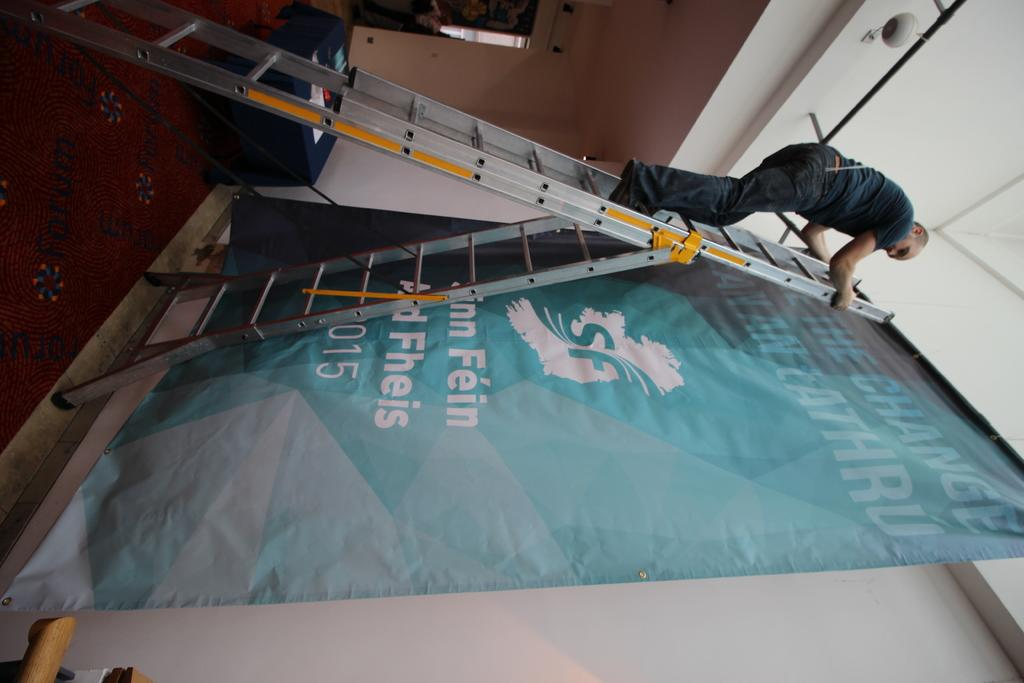What object is present in the image that allows someone to reach a higher position? There is a ladder in the image. Who is using the ladder in the image? A person is standing on the ladder. What is the person possibly trying to reach or access in the image? The person might be trying to reach the banner on the wall. What is hanging on the wall in the image? There is a banner on the wall, and it is on a stand. What is covering the floor in the image? There is a carpet on the floor. What piece of furniture is present in the image? There is a table in the image. What color is the mountain in the image? There is no mountain present in the image. Who is the owner of the ladder in the image? The image does not provide information about the ownership of the ladder. 